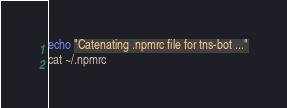Convert code to text. <code><loc_0><loc_0><loc_500><loc_500><_Bash_>
echo "Catenating .npmrc file for tns-bot ..."
cat ~/.npmrc</code> 